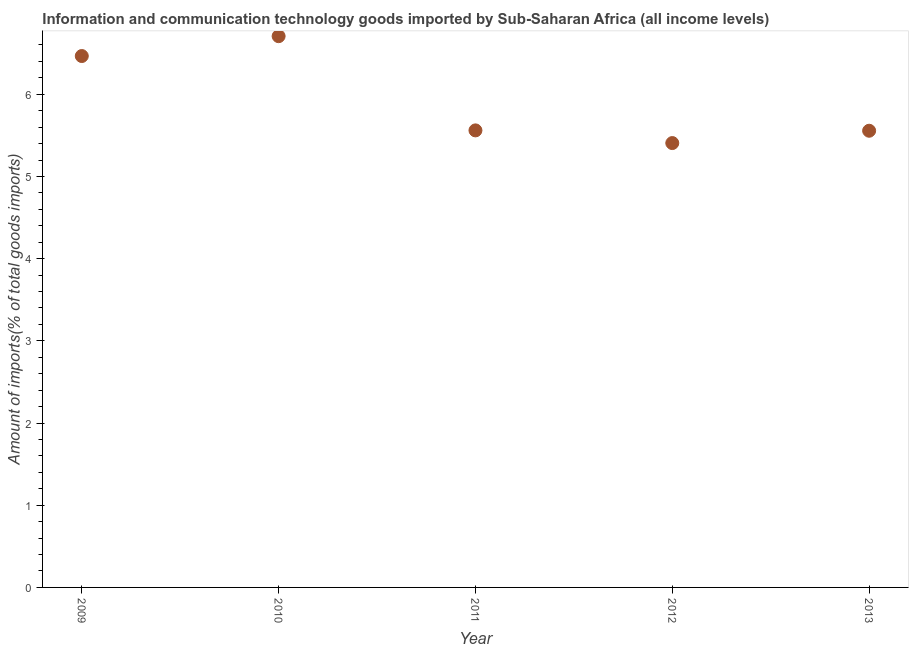What is the amount of ict goods imports in 2013?
Your answer should be compact. 5.56. Across all years, what is the maximum amount of ict goods imports?
Offer a very short reply. 6.71. Across all years, what is the minimum amount of ict goods imports?
Keep it short and to the point. 5.41. In which year was the amount of ict goods imports maximum?
Ensure brevity in your answer.  2010. What is the sum of the amount of ict goods imports?
Give a very brief answer. 29.69. What is the difference between the amount of ict goods imports in 2010 and 2012?
Give a very brief answer. 1.3. What is the average amount of ict goods imports per year?
Offer a very short reply. 5.94. What is the median amount of ict goods imports?
Your answer should be very brief. 5.56. In how many years, is the amount of ict goods imports greater than 1.2 %?
Offer a very short reply. 5. What is the ratio of the amount of ict goods imports in 2011 to that in 2013?
Make the answer very short. 1. Is the amount of ict goods imports in 2009 less than that in 2012?
Offer a terse response. No. What is the difference between the highest and the second highest amount of ict goods imports?
Provide a short and direct response. 0.24. What is the difference between the highest and the lowest amount of ict goods imports?
Keep it short and to the point. 1.3. In how many years, is the amount of ict goods imports greater than the average amount of ict goods imports taken over all years?
Offer a very short reply. 2. Does the amount of ict goods imports monotonically increase over the years?
Ensure brevity in your answer.  No. How many dotlines are there?
Give a very brief answer. 1. How many years are there in the graph?
Make the answer very short. 5. Are the values on the major ticks of Y-axis written in scientific E-notation?
Your answer should be compact. No. Does the graph contain grids?
Offer a terse response. No. What is the title of the graph?
Your answer should be compact. Information and communication technology goods imported by Sub-Saharan Africa (all income levels). What is the label or title of the X-axis?
Offer a very short reply. Year. What is the label or title of the Y-axis?
Ensure brevity in your answer.  Amount of imports(% of total goods imports). What is the Amount of imports(% of total goods imports) in 2009?
Ensure brevity in your answer.  6.46. What is the Amount of imports(% of total goods imports) in 2010?
Make the answer very short. 6.71. What is the Amount of imports(% of total goods imports) in 2011?
Provide a succinct answer. 5.56. What is the Amount of imports(% of total goods imports) in 2012?
Your answer should be compact. 5.41. What is the Amount of imports(% of total goods imports) in 2013?
Make the answer very short. 5.56. What is the difference between the Amount of imports(% of total goods imports) in 2009 and 2010?
Offer a terse response. -0.24. What is the difference between the Amount of imports(% of total goods imports) in 2009 and 2011?
Offer a very short reply. 0.9. What is the difference between the Amount of imports(% of total goods imports) in 2009 and 2012?
Make the answer very short. 1.06. What is the difference between the Amount of imports(% of total goods imports) in 2009 and 2013?
Keep it short and to the point. 0.91. What is the difference between the Amount of imports(% of total goods imports) in 2010 and 2011?
Give a very brief answer. 1.15. What is the difference between the Amount of imports(% of total goods imports) in 2010 and 2012?
Your answer should be compact. 1.3. What is the difference between the Amount of imports(% of total goods imports) in 2010 and 2013?
Offer a very short reply. 1.15. What is the difference between the Amount of imports(% of total goods imports) in 2011 and 2012?
Your answer should be very brief. 0.15. What is the difference between the Amount of imports(% of total goods imports) in 2011 and 2013?
Your answer should be compact. 0. What is the difference between the Amount of imports(% of total goods imports) in 2012 and 2013?
Your response must be concise. -0.15. What is the ratio of the Amount of imports(% of total goods imports) in 2009 to that in 2010?
Offer a terse response. 0.96. What is the ratio of the Amount of imports(% of total goods imports) in 2009 to that in 2011?
Your response must be concise. 1.16. What is the ratio of the Amount of imports(% of total goods imports) in 2009 to that in 2012?
Give a very brief answer. 1.2. What is the ratio of the Amount of imports(% of total goods imports) in 2009 to that in 2013?
Offer a terse response. 1.16. What is the ratio of the Amount of imports(% of total goods imports) in 2010 to that in 2011?
Keep it short and to the point. 1.21. What is the ratio of the Amount of imports(% of total goods imports) in 2010 to that in 2012?
Your answer should be very brief. 1.24. What is the ratio of the Amount of imports(% of total goods imports) in 2010 to that in 2013?
Give a very brief answer. 1.21. What is the ratio of the Amount of imports(% of total goods imports) in 2011 to that in 2013?
Keep it short and to the point. 1. 